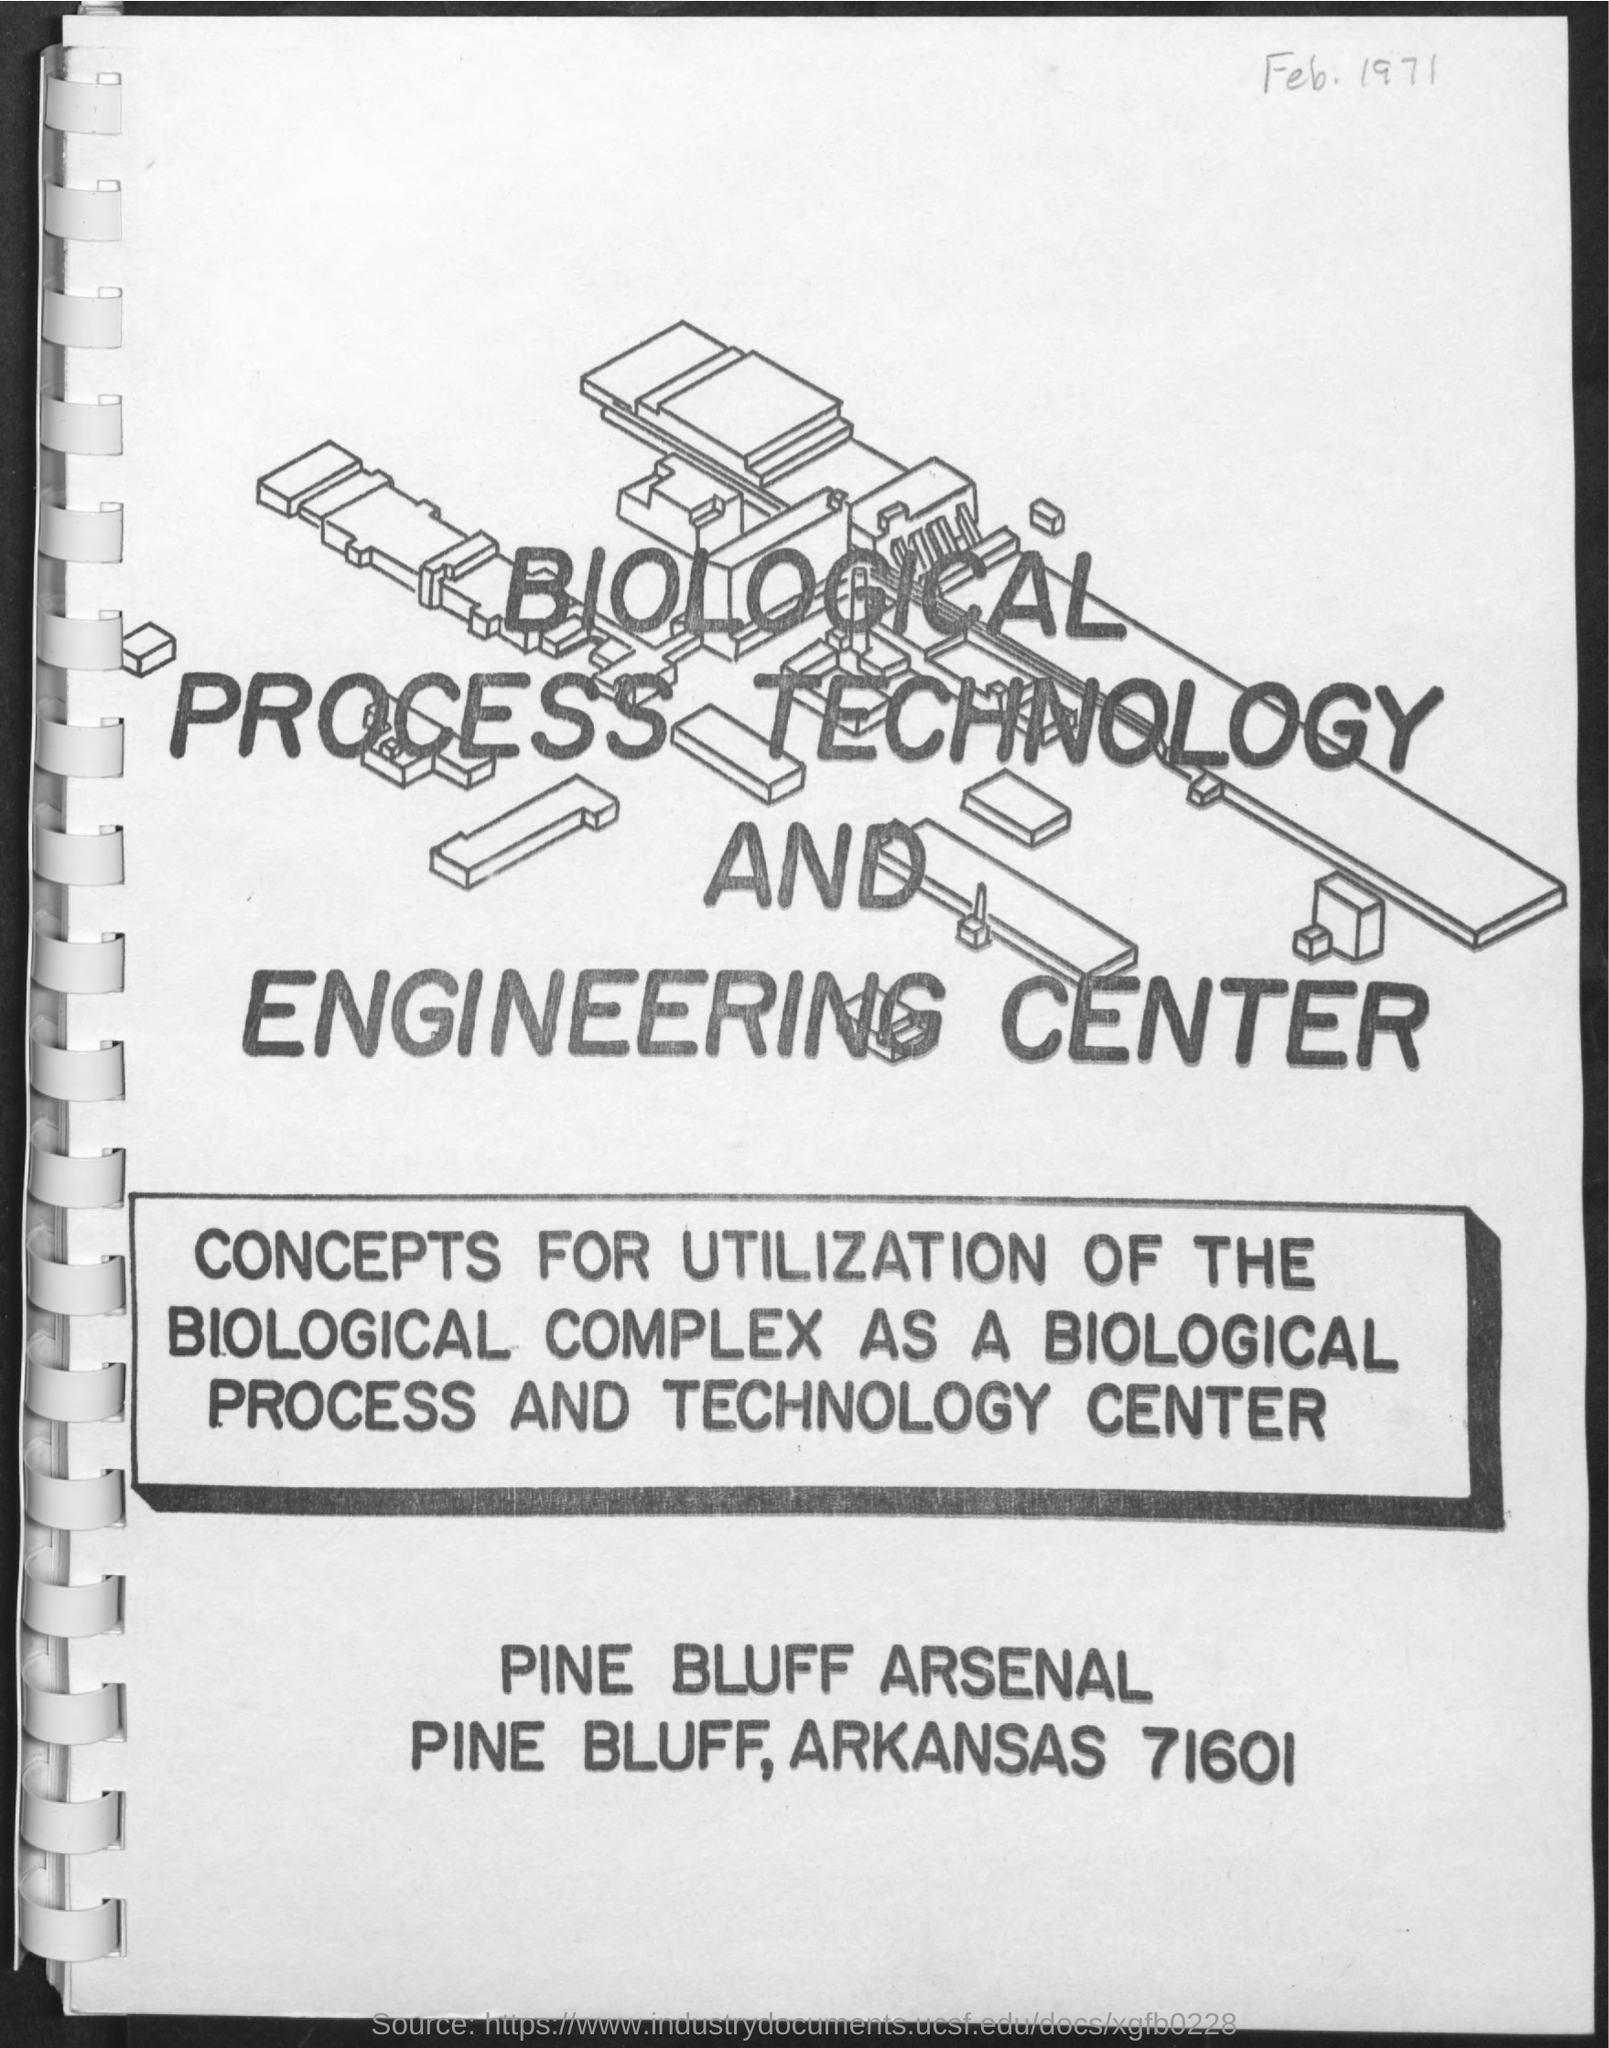Indicate a few pertinent items in this graphic. The title of the document is the Biological Process Technology and Engineering Center. The date mentioned in the document is February 1971. 